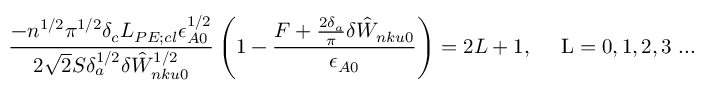Convert formula to latex. <formula><loc_0><loc_0><loc_500><loc_500>\frac { - n ^ { 1 / 2 } \pi ^ { 1 / 2 } \delta _ { c } L _ { P E ; c l } \epsilon _ { A 0 } ^ { 1 / 2 } } { 2 \sqrt { 2 } S \delta _ { a } ^ { 1 / 2 } \delta { \hat { W } } _ { n k u 0 } ^ { 1 / 2 } } \left ( 1 - \frac { F + \frac { 2 \delta _ { a } } { \pi } \delta { \hat { W } } _ { n k u 0 } } { \epsilon _ { A 0 } } \right ) = 2 L + 1 , { \quad L = 0 , 1 , 2 , 3 \dots }</formula> 